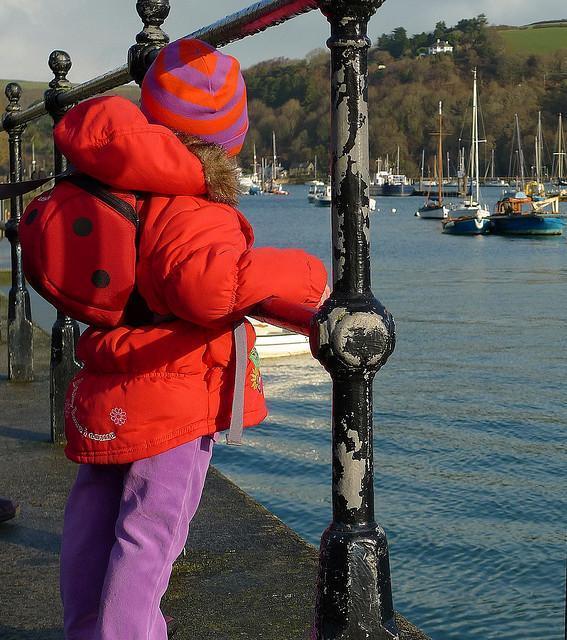How many zebras are facing left?
Give a very brief answer. 0. 